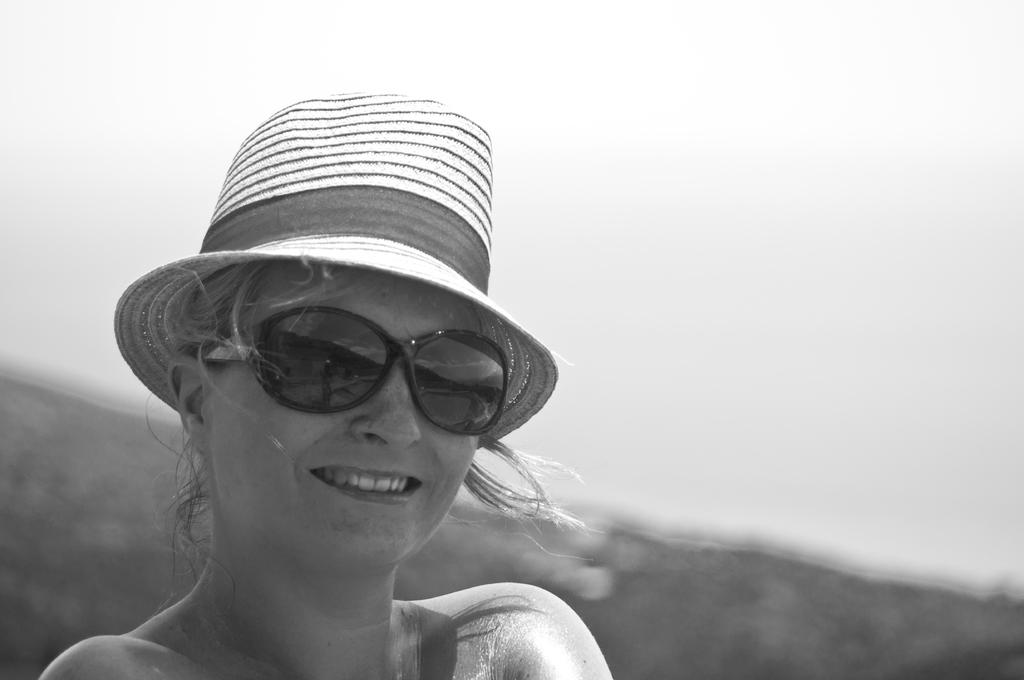Who is the main subject in the picture? There is a woman in the picture. What is the woman wearing on her head? The woman is wearing a cap. What type of eyewear is the woman wearing? The woman is wearing sunglasses. How would you describe the sky in the picture? The sky is cloudy in the picture. What type of whip is the woman using to create a rhythm in the park? There is no whip or park present in the image, and the woman is not creating any rhythm. 